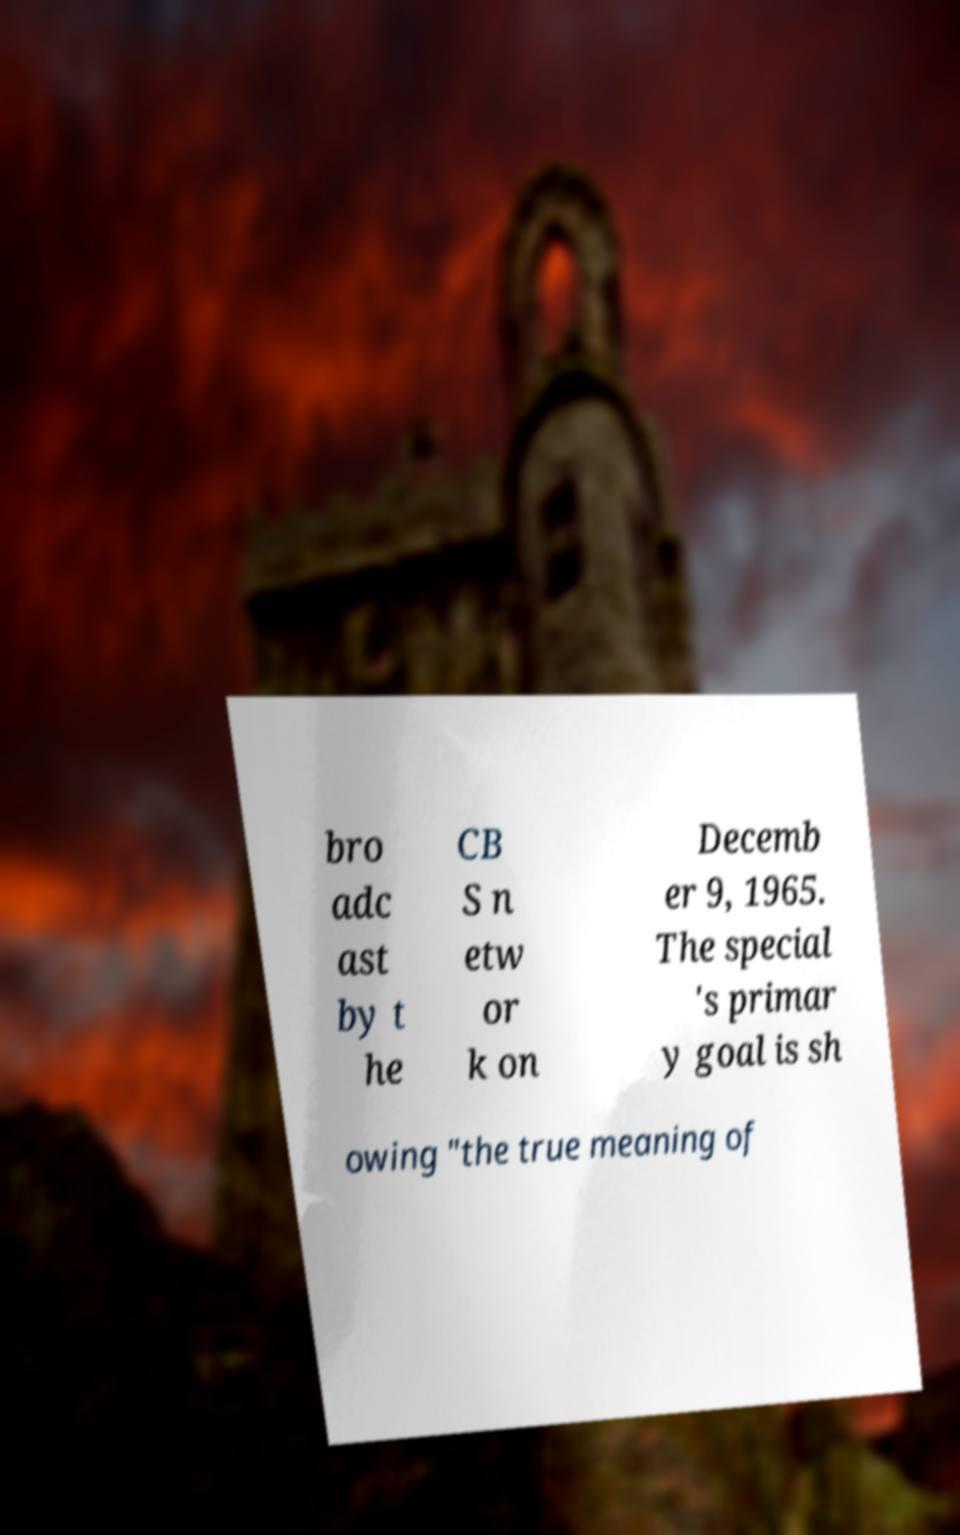Can you read and provide the text displayed in the image?This photo seems to have some interesting text. Can you extract and type it out for me? bro adc ast by t he CB S n etw or k on Decemb er 9, 1965. The special 's primar y goal is sh owing "the true meaning of 